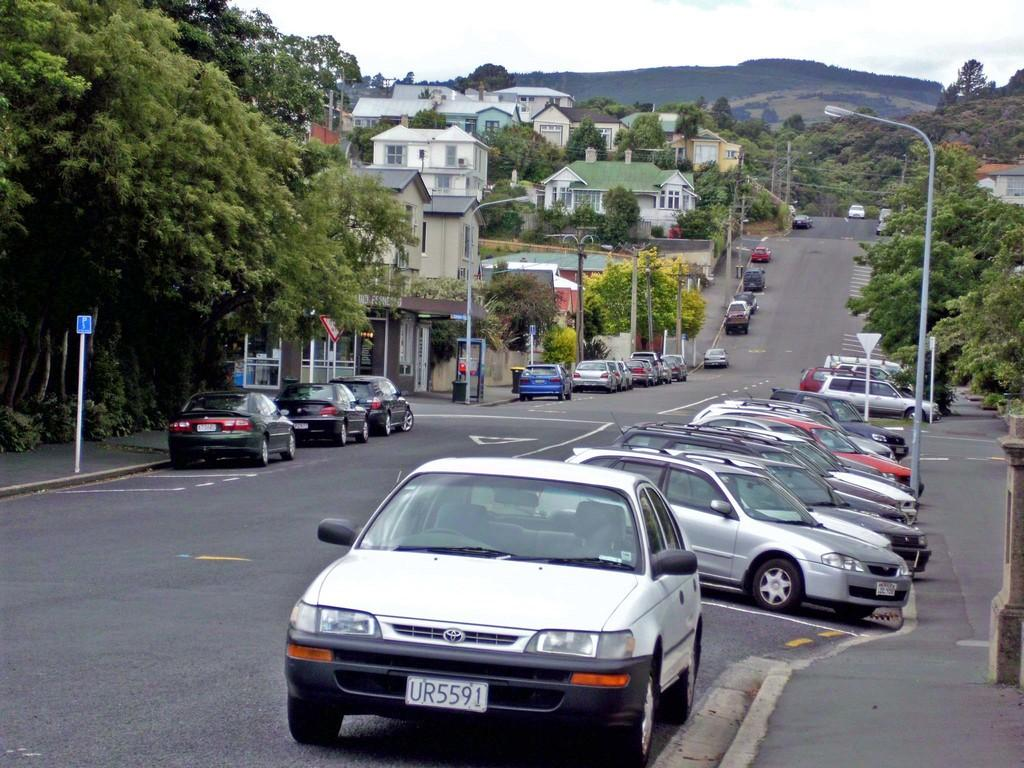Where was the image taken? The image was clicked outside. What can be seen in the middle of the image? There are trees and buildings in the middle of the image. What is parked on the road in the image? There are cars parked on the road in the image. What is visible at the top of the image? The sky is visible at the top of the image. Can you see a street performer attempting to juggle a ball in the image? There is no street performer or ball present in the image. 